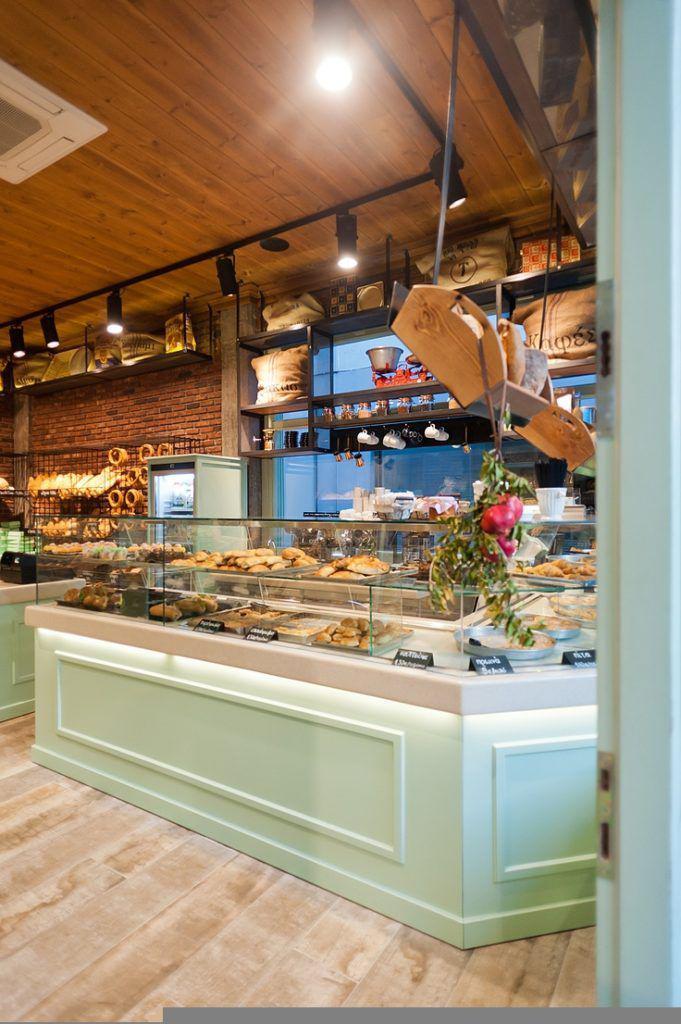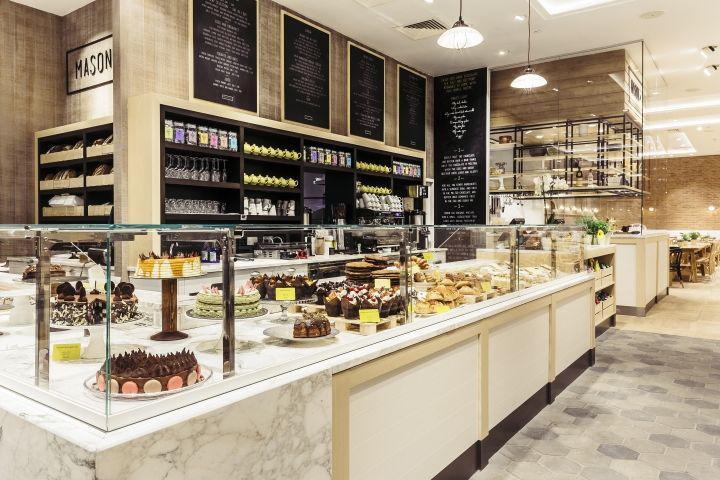The first image is the image on the left, the second image is the image on the right. Examine the images to the left and right. Is the description "There are exactly five lights hanging above the counter in the image on the right." accurate? Answer yes or no. No. 